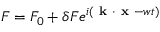Convert formula to latex. <formula><loc_0><loc_0><loc_500><loc_500>F = F _ { 0 } + \delta F e ^ { i ( k \cdot x - w t ) }</formula> 